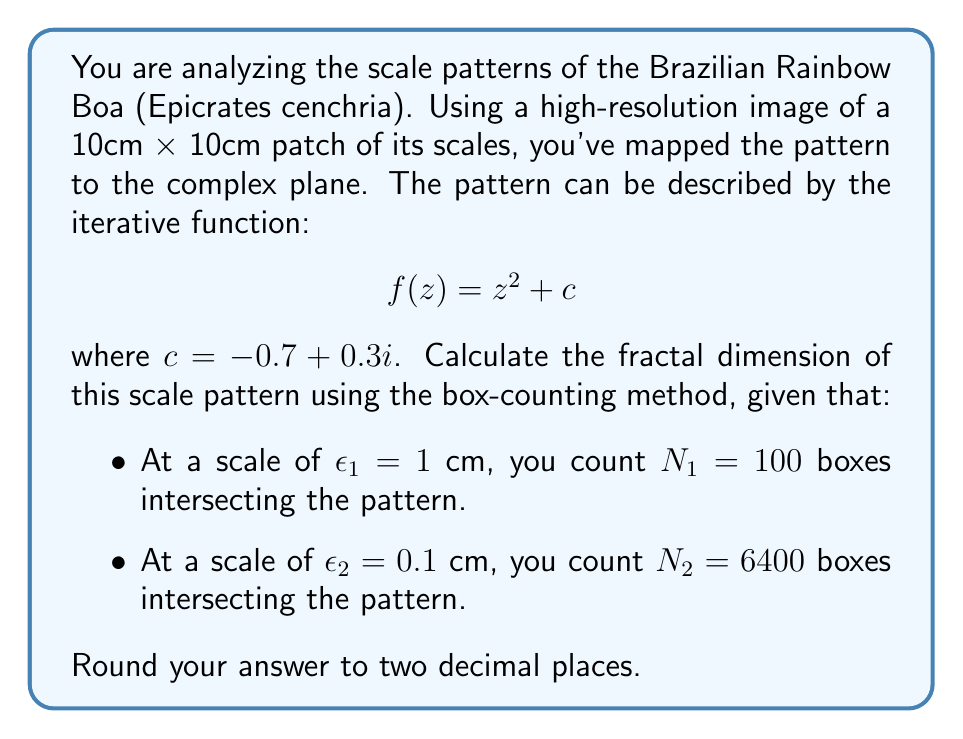Can you solve this math problem? To calculate the fractal dimension using the box-counting method, we use the following steps:

1) The fractal dimension $D$ is given by the formula:

   $$D = \lim_{\epsilon \to 0} \frac{\log N(\epsilon)}{\log(1/\epsilon)}$$

   where $N(\epsilon)$ is the number of boxes of side length $\epsilon$ needed to cover the set.

2) In practice, we can estimate $D$ using two different scales:

   $$D \approx \frac{\log(N_2/N_1)}{\log(\epsilon_1/\epsilon_2)}$$

3) Substituting our values:
   
   $$D \approx \frac{\log(6400/100)}{\log(1/0.1)}$$

4) Simplify:
   
   $$D \approx \frac{\log(64)}{\log(10)}$$

5) Calculate:
   
   $$D \approx \frac{6.0205999132796239042747778944899}{2.3025850929940456840179914546844}$$

6) Divide:
   
   $$D \approx 1.8149091624929434209638310576934$$

7) Round to two decimal places:
   
   $$D \approx 1.81$$

This fractal dimension between 1 and 2 indicates a pattern that is more complex than a simple line (dimension 1) but does not completely fill the plane (dimension 2), which is typical for natural patterns like reptile scales.
Answer: $1.81$ 